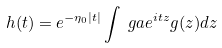<formula> <loc_0><loc_0><loc_500><loc_500>h ( t ) = e ^ { - \eta _ { 0 } | t | } \int _ { \ } g a e ^ { i t z } g ( z ) d z</formula> 